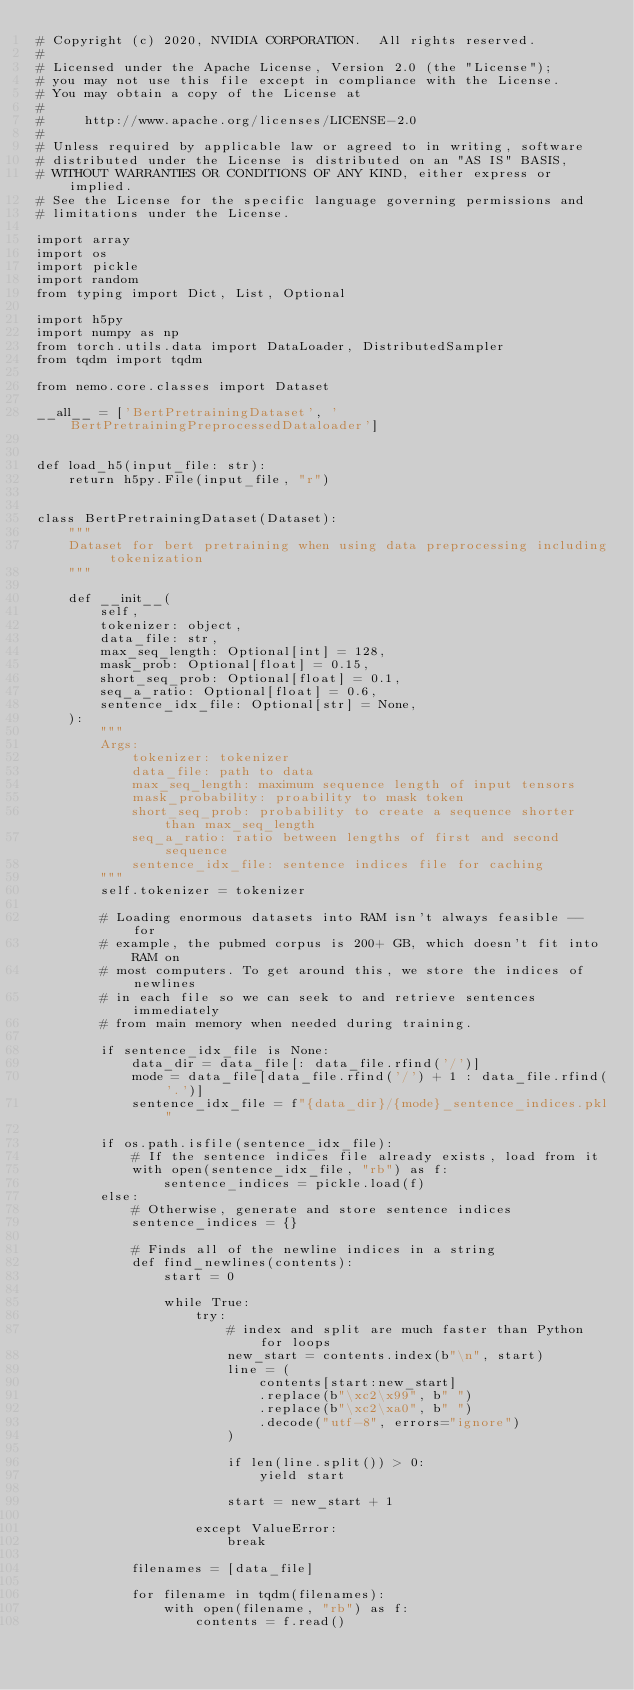Convert code to text. <code><loc_0><loc_0><loc_500><loc_500><_Python_># Copyright (c) 2020, NVIDIA CORPORATION.  All rights reserved.
#
# Licensed under the Apache License, Version 2.0 (the "License");
# you may not use this file except in compliance with the License.
# You may obtain a copy of the License at
#
#     http://www.apache.org/licenses/LICENSE-2.0
#
# Unless required by applicable law or agreed to in writing, software
# distributed under the License is distributed on an "AS IS" BASIS,
# WITHOUT WARRANTIES OR CONDITIONS OF ANY KIND, either express or implied.
# See the License for the specific language governing permissions and
# limitations under the License.

import array
import os
import pickle
import random
from typing import Dict, List, Optional

import h5py
import numpy as np
from torch.utils.data import DataLoader, DistributedSampler
from tqdm import tqdm

from nemo.core.classes import Dataset

__all__ = ['BertPretrainingDataset', 'BertPretrainingPreprocessedDataloader']


def load_h5(input_file: str):
    return h5py.File(input_file, "r")


class BertPretrainingDataset(Dataset):
    """
    Dataset for bert pretraining when using data preprocessing including tokenization
    """

    def __init__(
        self,
        tokenizer: object,
        data_file: str,
        max_seq_length: Optional[int] = 128,
        mask_prob: Optional[float] = 0.15,
        short_seq_prob: Optional[float] = 0.1,
        seq_a_ratio: Optional[float] = 0.6,
        sentence_idx_file: Optional[str] = None,
    ):
        """
        Args:
            tokenizer: tokenizer
            data_file: path to data
            max_seq_length: maximum sequence length of input tensors
            mask_probability: proability to mask token
            short_seq_prob: probability to create a sequence shorter than max_seq_length
            seq_a_ratio: ratio between lengths of first and second sequence
            sentence_idx_file: sentence indices file for caching
        """
        self.tokenizer = tokenizer

        # Loading enormous datasets into RAM isn't always feasible -- for
        # example, the pubmed corpus is 200+ GB, which doesn't fit into RAM on
        # most computers. To get around this, we store the indices of newlines
        # in each file so we can seek to and retrieve sentences immediately
        # from main memory when needed during training.

        if sentence_idx_file is None:
            data_dir = data_file[: data_file.rfind('/')]
            mode = data_file[data_file.rfind('/') + 1 : data_file.rfind('.')]
            sentence_idx_file = f"{data_dir}/{mode}_sentence_indices.pkl"

        if os.path.isfile(sentence_idx_file):
            # If the sentence indices file already exists, load from it
            with open(sentence_idx_file, "rb") as f:
                sentence_indices = pickle.load(f)
        else:
            # Otherwise, generate and store sentence indices
            sentence_indices = {}

            # Finds all of the newline indices in a string
            def find_newlines(contents):
                start = 0

                while True:
                    try:
                        # index and split are much faster than Python for loops
                        new_start = contents.index(b"\n", start)
                        line = (
                            contents[start:new_start]
                            .replace(b"\xc2\x99", b" ")
                            .replace(b"\xc2\xa0", b" ")
                            .decode("utf-8", errors="ignore")
                        )

                        if len(line.split()) > 0:
                            yield start

                        start = new_start + 1

                    except ValueError:
                        break

            filenames = [data_file]

            for filename in tqdm(filenames):
                with open(filename, "rb") as f:
                    contents = f.read()</code> 